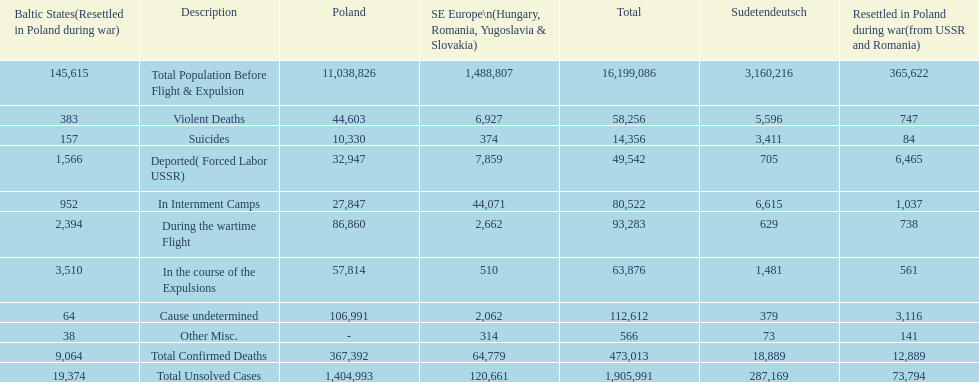Which region had the least total of unsolved cases? Baltic States(Resettled in Poland during war). 